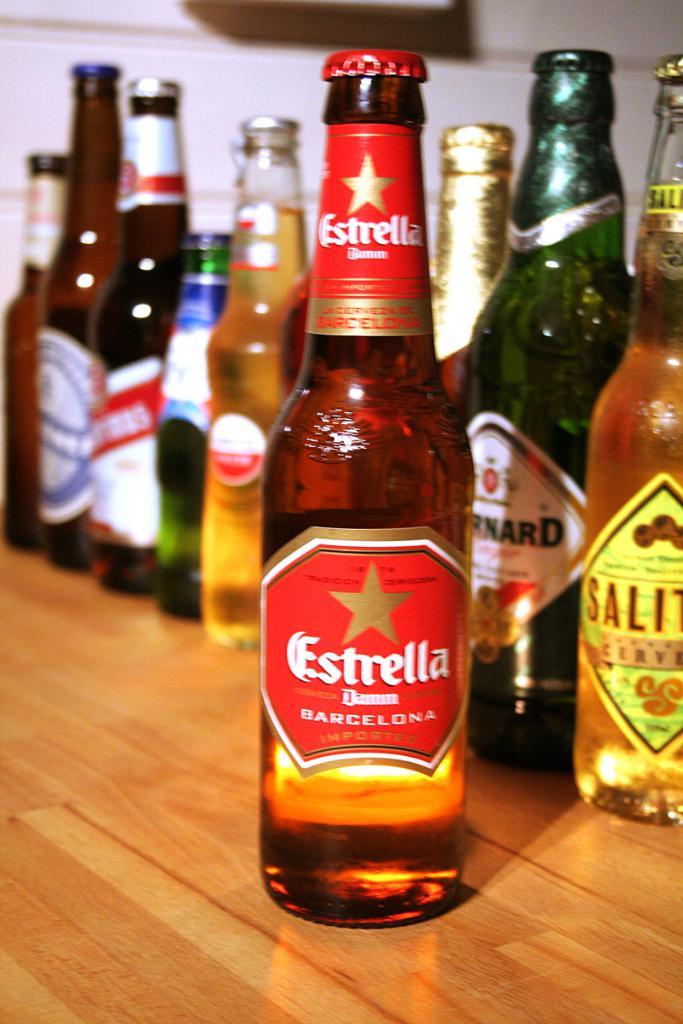What is the brand name of the beer in the middle?
Make the answer very short. Estrella. How many brand of beers are there?
Make the answer very short. 8. 